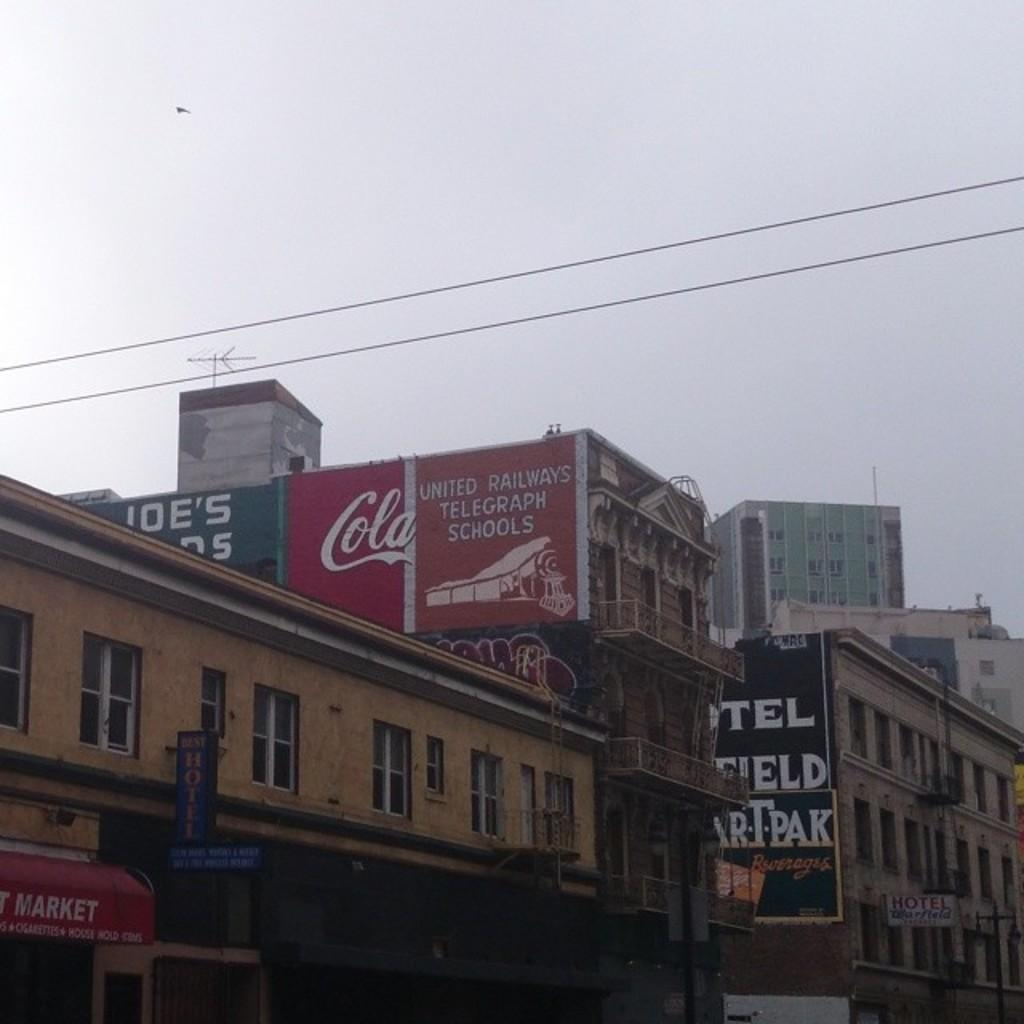<image>
Give a short and clear explanation of the subsequent image. several signs are painted on the side of a building including a telegraph school one 